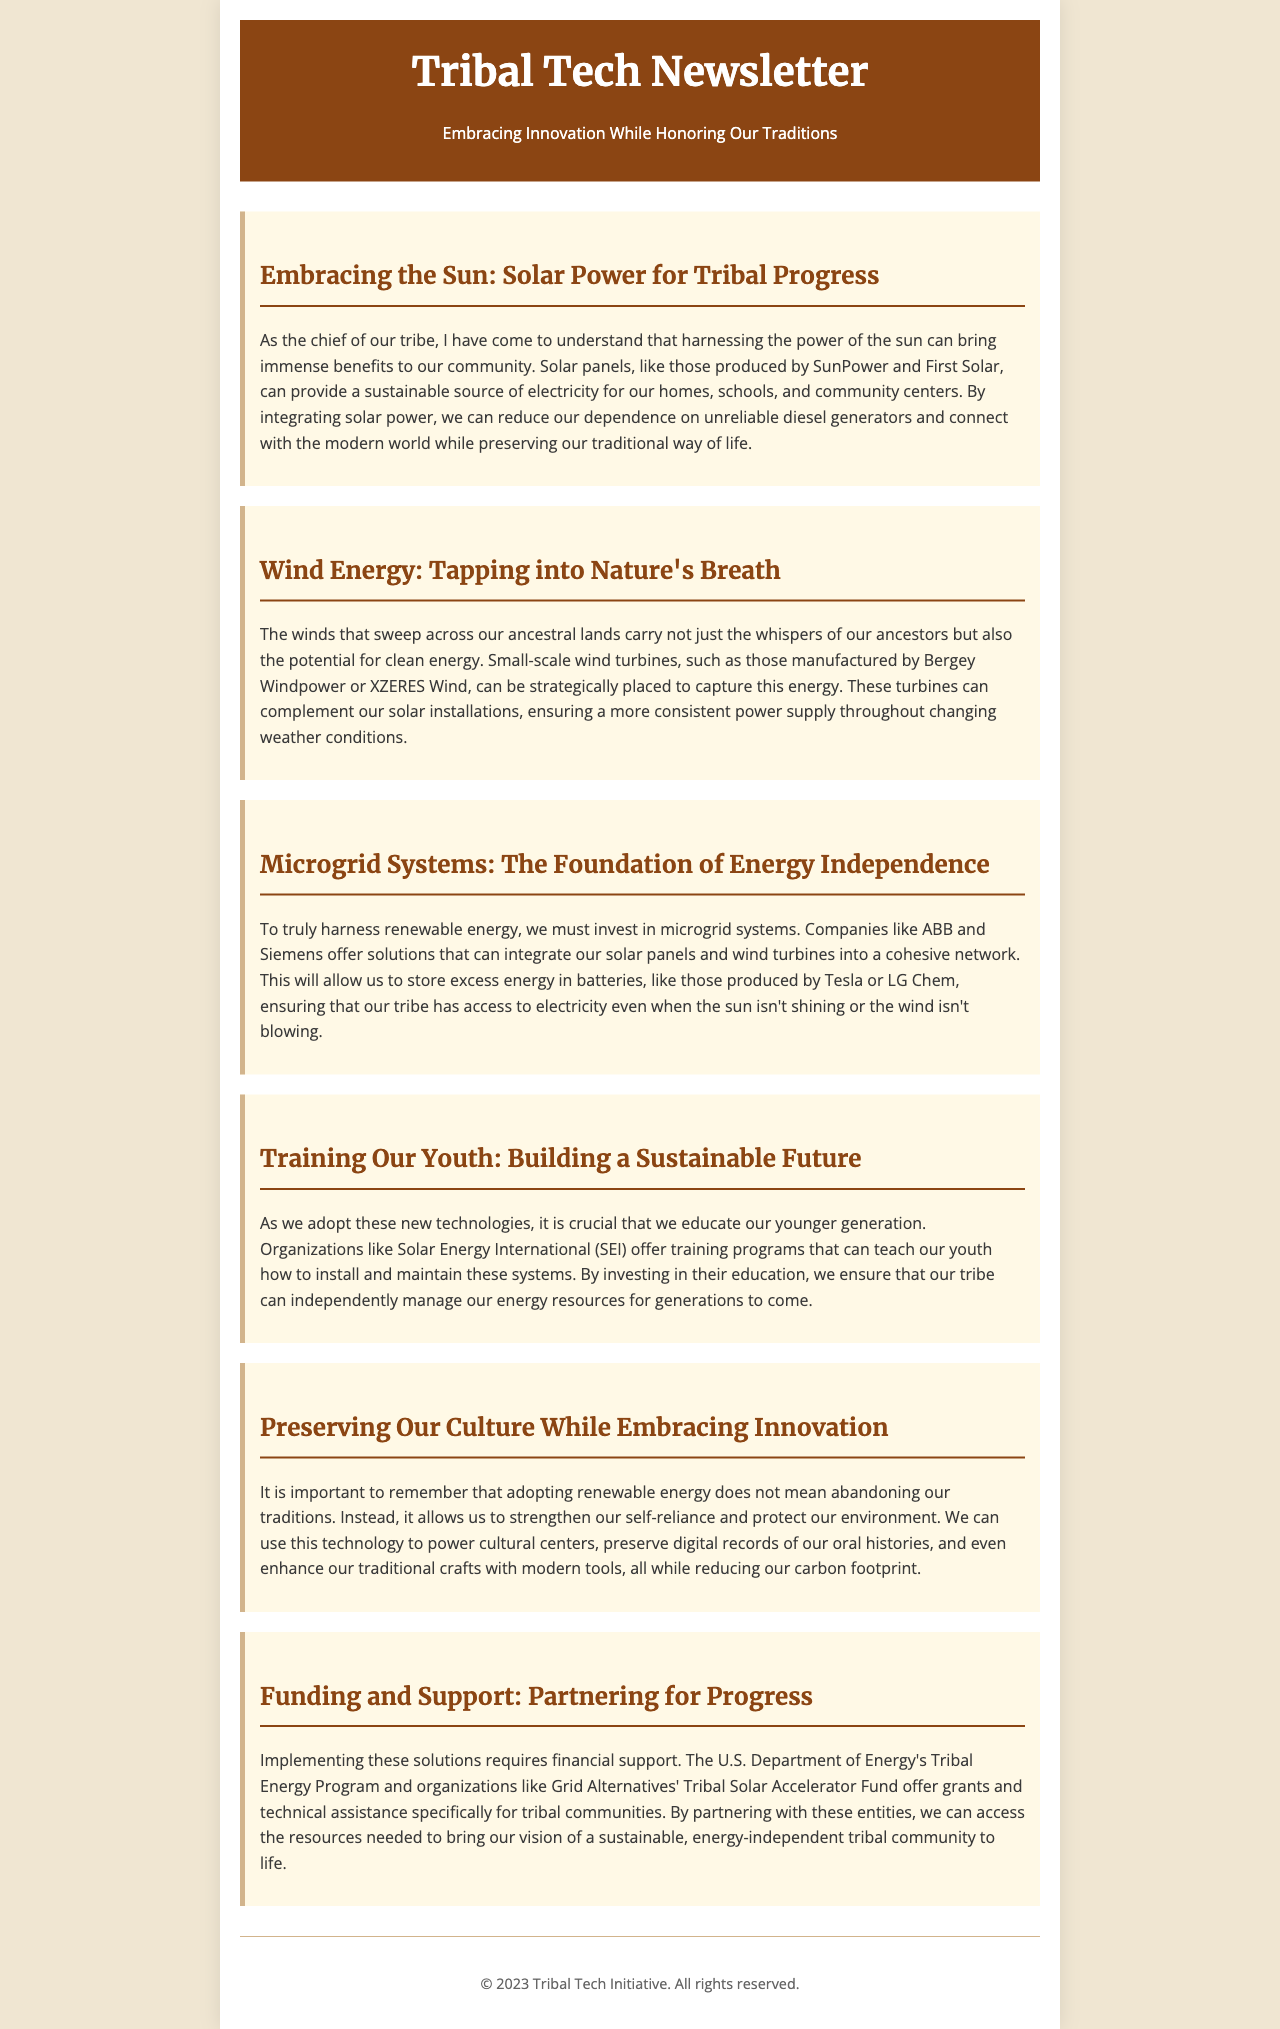What is the title of the first section? The title of the first section is clearly labeled in the document as the header of the section, which is "Embracing the Sun: Solar Power for Tribal Progress."
Answer: Embracing the Sun: Solar Power for Tribal Progress Which companies are mentioned for solar panel production? The document lists specific companies involved in producing solar panels within the first section, which include SunPower and First Solar.
Answer: SunPower and First Solar What type of energy is described in the second section? The second section specifically focuses on a type of energy that can be harnessed from winds in the tribal lands.
Answer: Wind energy What companies provide microgrid solutions? The document mentions companies that offer solutions for microgrid systems in the third section, which are ABB and Siemens.
Answer: ABB and Siemens What is the purpose of training programs mentioned in the document? The training programs are aimed at educating the younger generation on how to install and maintain renewable energy systems, ensuring self-management of energy resources.
Answer: To educate youth on energy systems How do renewable energy solutions affect tribal traditions? The document explains that adopting renewable energy solutions can strengthen self-reliance and help preserve traditions rather than replace them.
Answer: They strengthen self-reliance and preserve traditions What type of financial support is available for implementing renewable energy? The document outlines funding opportunities available specifically aimed at tribal communities, particularly through the U.S. Department of Energy's programs and other organizations.
Answer: Grants and technical assistance 